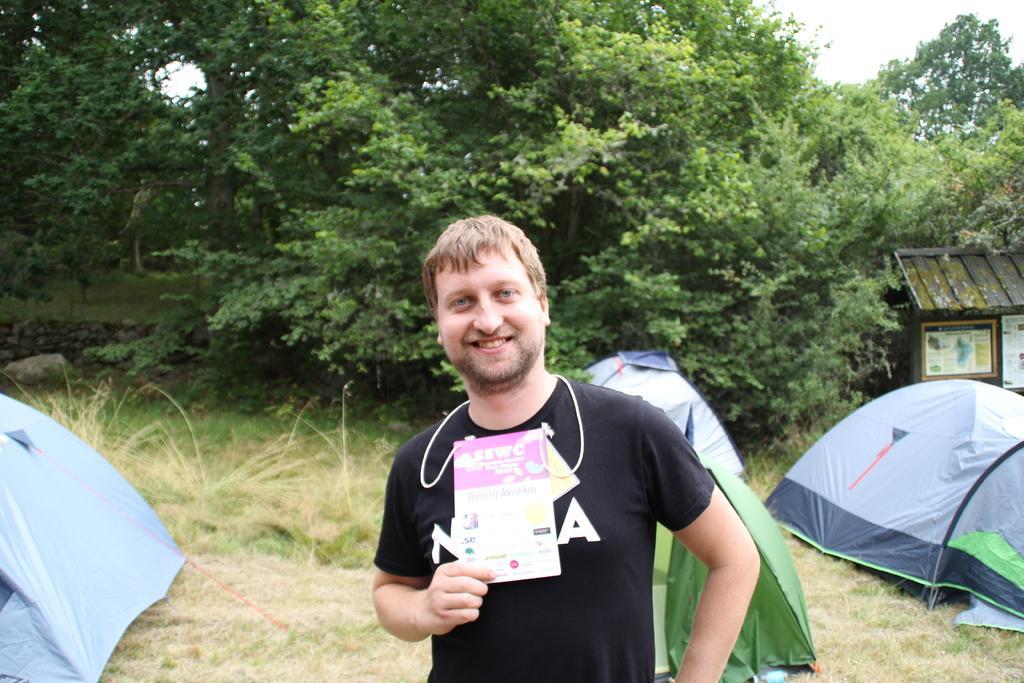How would you summarize this image in a sentence or two? In this image I can see a person standing holding a card. The person is wearing black shirt, background I can see few tents, trees in green color, sky in white color. 